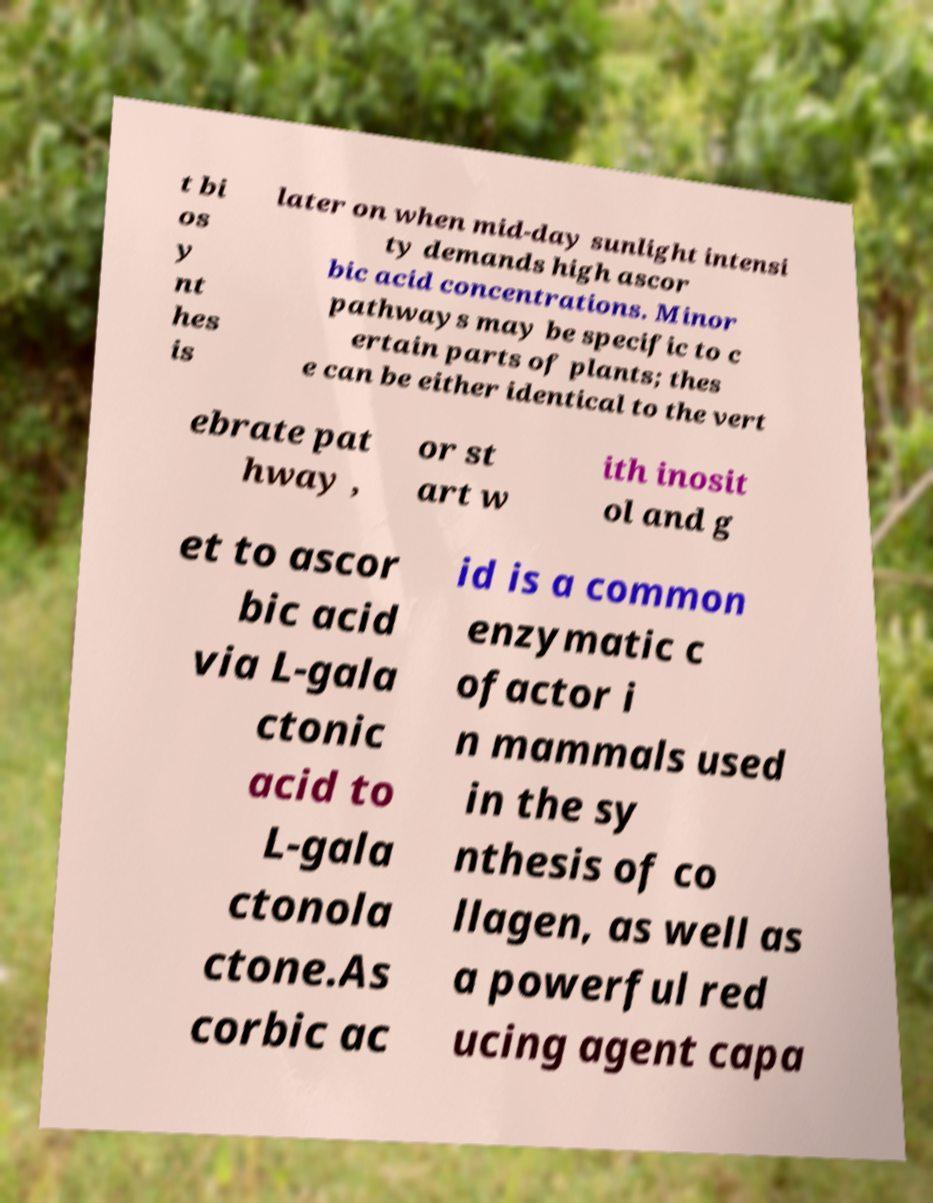What messages or text are displayed in this image? I need them in a readable, typed format. t bi os y nt hes is later on when mid-day sunlight intensi ty demands high ascor bic acid concentrations. Minor pathways may be specific to c ertain parts of plants; thes e can be either identical to the vert ebrate pat hway , or st art w ith inosit ol and g et to ascor bic acid via L-gala ctonic acid to L-gala ctonola ctone.As corbic ac id is a common enzymatic c ofactor i n mammals used in the sy nthesis of co llagen, as well as a powerful red ucing agent capa 